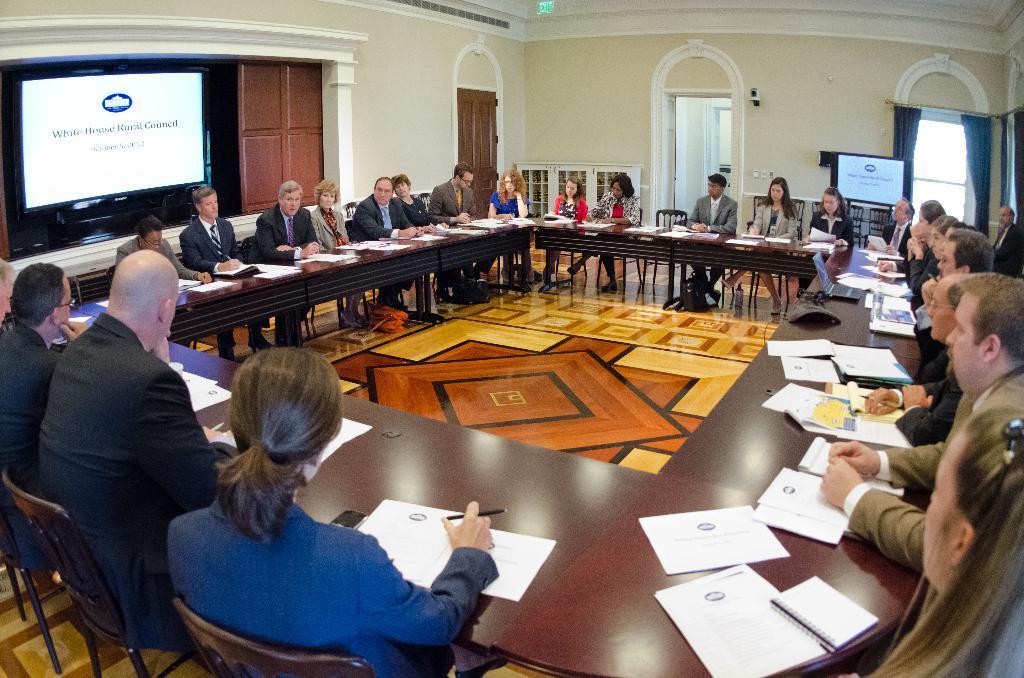Could you give a brief overview of what you see in this image? This image is taken in the conference room. In this image we can see there are some people sitting on chairs. In front of them there is a table. On the table there are a few papers and a few people are holding pens. On the left side of the image there is a screen. In the background there is a door and window attached to the wall. 